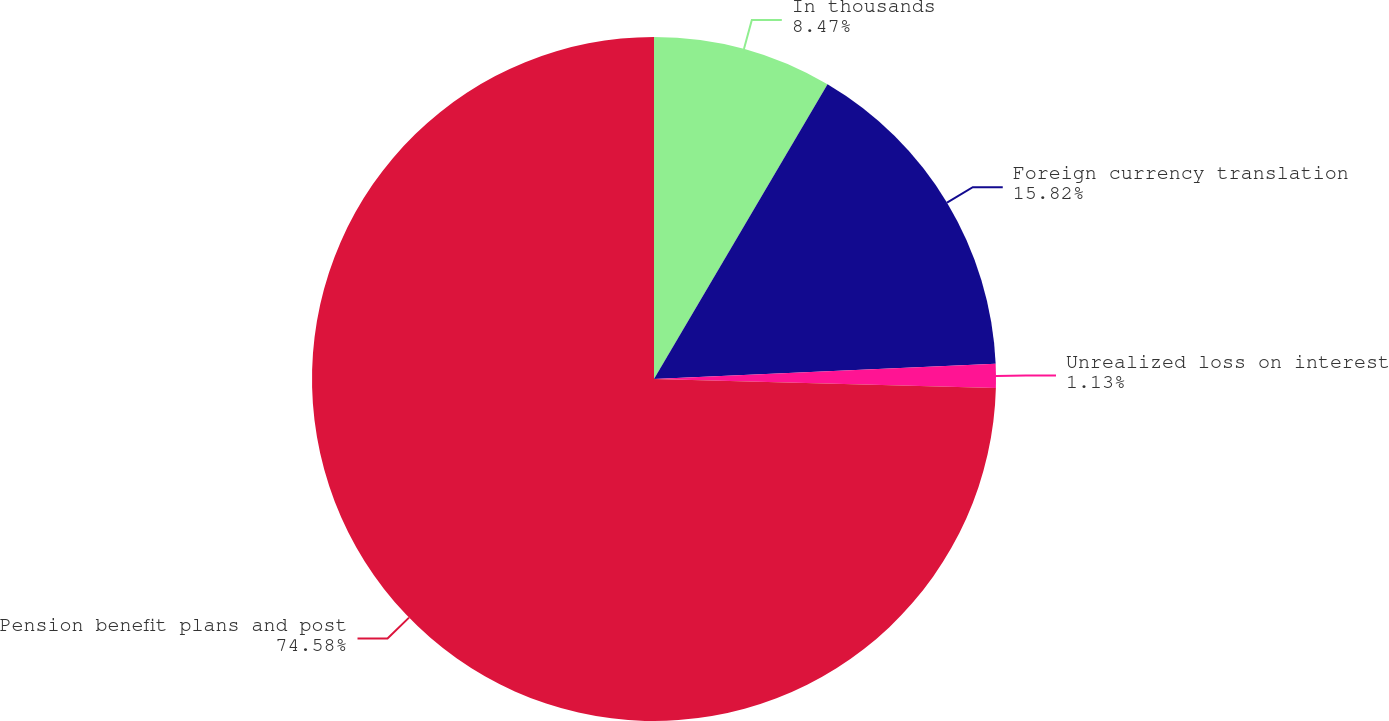Convert chart. <chart><loc_0><loc_0><loc_500><loc_500><pie_chart><fcel>In thousands<fcel>Foreign currency translation<fcel>Unrealized loss on interest<fcel>Pension benefit plans and post<nl><fcel>8.47%<fcel>15.82%<fcel>1.13%<fcel>74.58%<nl></chart> 